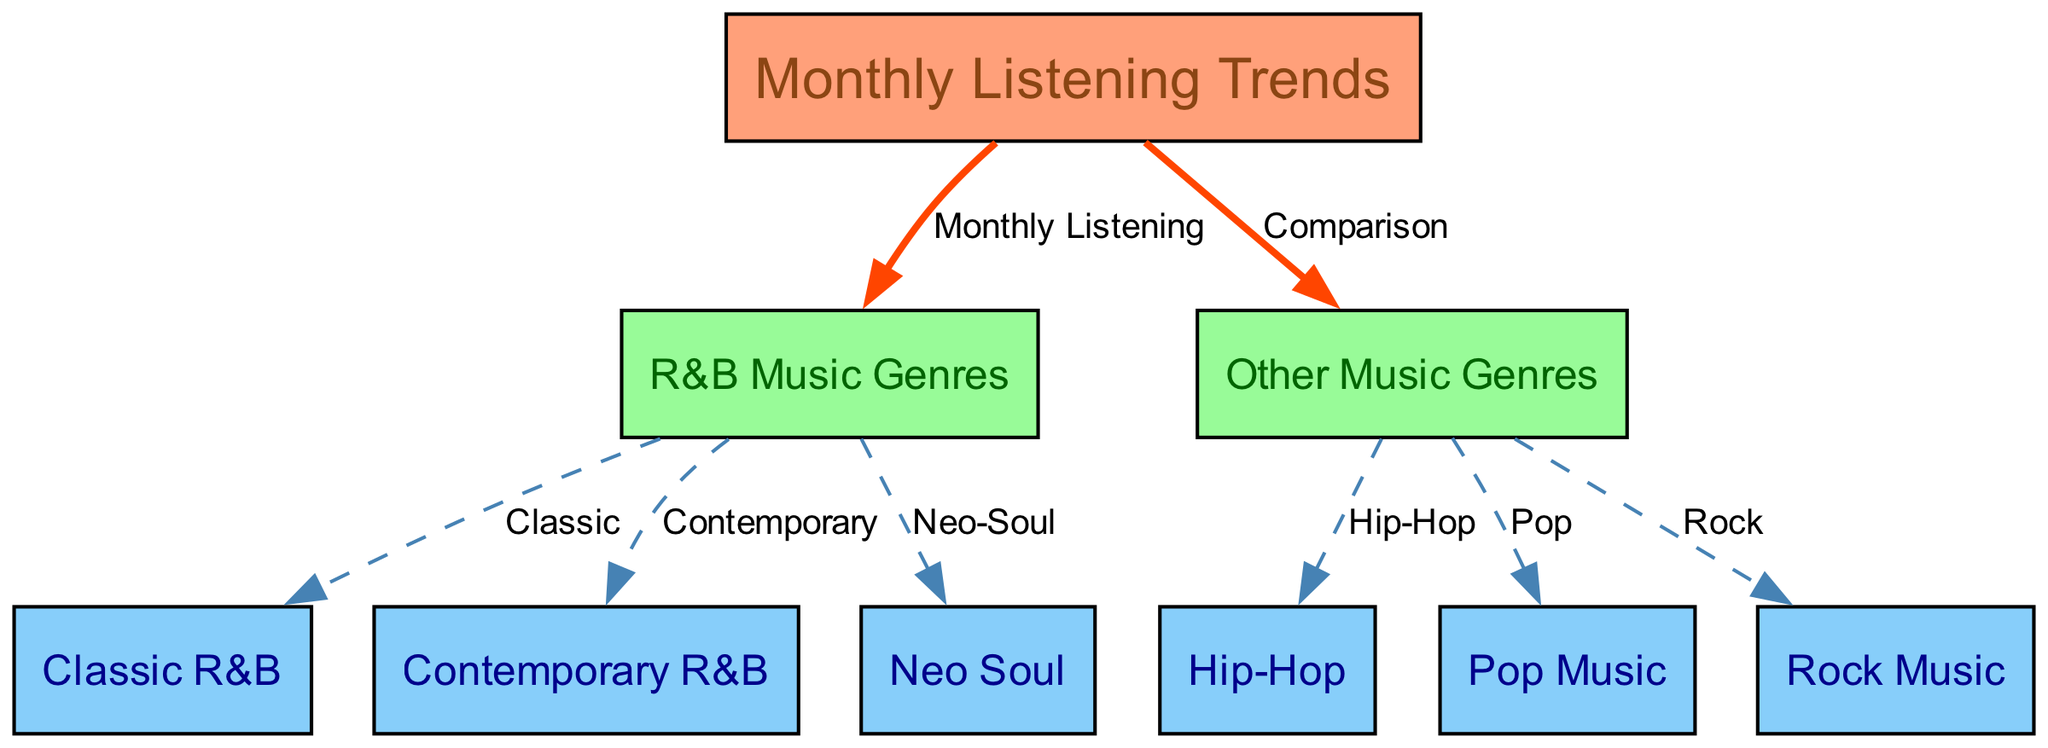What is the main focus of the diagram? The main focus of the diagram is to represent "Monthly Listening Trends" which is evident from the central node labeled as such.
Answer: Monthly Listening Trends How many R&B music genre nodes are present? There are three nodes representing R&B music genres, which are "Classic R&B," "Contemporary R&B," and "Neo Soul." Counting these tells us the total.
Answer: 3 What type of edge connects "monthly listening trends" to "rnb music genres"? The edge connecting these two nodes is labeled as "Monthly Listening," indicating the nature of the relationship. The specific edge type suggests a direct relationship without comparison.
Answer: Monthly Listening Can you name one genre compared to R&B music genres? The diagram indicates that "Hip-Hop," "Pop Music," and "Rock Music" are compared to R&B music genres, and any one of these would be correct.
Answer: Hip-Hop Which R&B genre is classified as "Neo-Soul"? "Neo Soul" is specifically designated as one of the subcategories within R&B music genres as indicated in the diagram. Thus, it directly serves as the name of that node.
Answer: Neo Soul Which other music genre has a dashed edge indicating comparison with R&B? The dashed edges indicate comparisons of "Hip-Hop," "Pop Music," and "Rock Music" with R&B, with any of these being an appropriate answer.
Answer: Pop Music How many edges originate from "other music genres"? There are three edges stemming from "other music genres" identifying distinct comparisons made to various other music types. This count can be confirmed by checking the connections.
Answer: 3 What color represents R&B music genres in the diagram? The R&B music genres are represented in a light green color scheme, which stands out from other nodes in the diagram.
Answer: Light Green Which node is directly connected to both "classic rnb" and "contemporary rnb"? The node "rnb music genres" is the one that connects directly to both "classic rnb" and "contemporary rnb," as it's the parent node in this hierarchy.
Answer: R&B Music Genres 